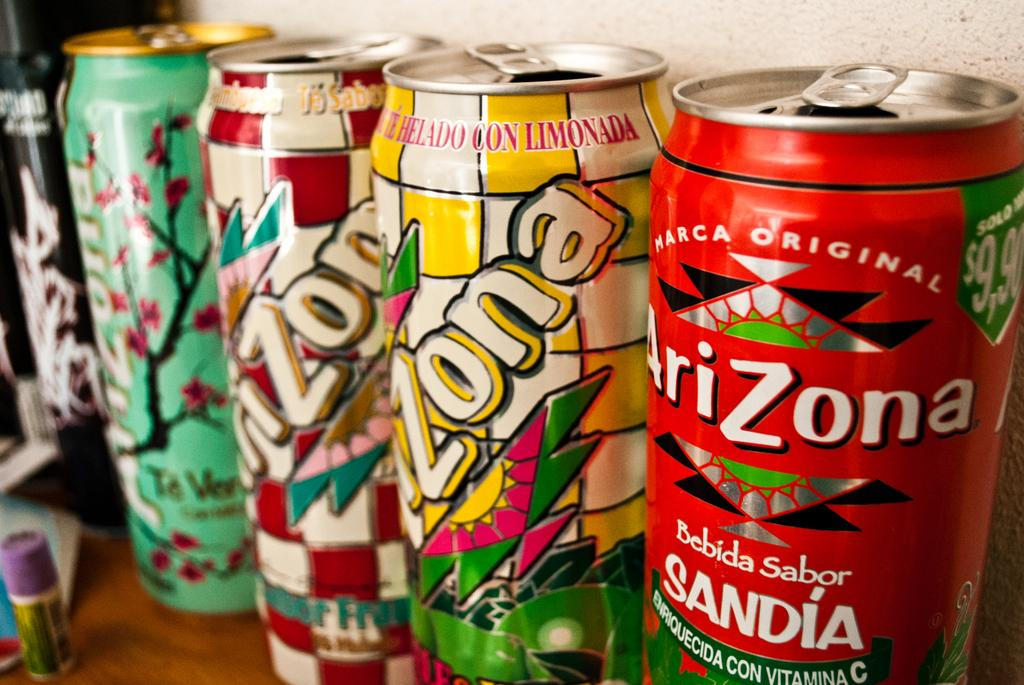<image>
Present a compact description of the photo's key features. Different varieties of Arizona Tea cans lined up in a row. 